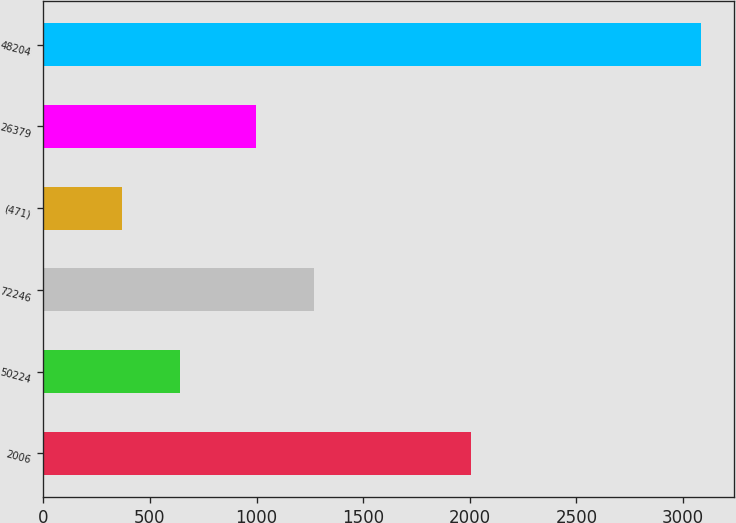Convert chart to OTSL. <chart><loc_0><loc_0><loc_500><loc_500><bar_chart><fcel>2006<fcel>50224<fcel>72246<fcel>(471)<fcel>26379<fcel>48204<nl><fcel>2004<fcel>642.2<fcel>1267.2<fcel>371<fcel>996<fcel>3083<nl></chart> 